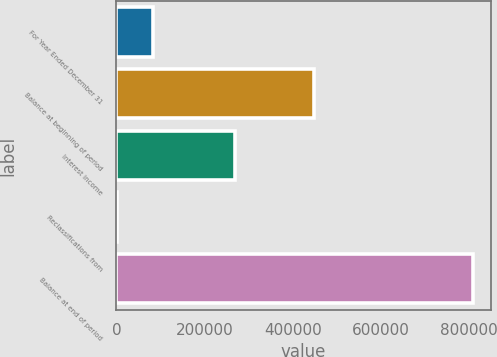Convert chart to OTSL. <chart><loc_0><loc_0><loc_500><loc_500><bar_chart><fcel>For Year Ended December 31<fcel>Balance at beginning of period<fcel>Interest income<fcel>Reclassifications from<fcel>Balance at end of period<nl><fcel>82416<fcel>447505<fcel>268315<fcel>1800<fcel>807960<nl></chart> 